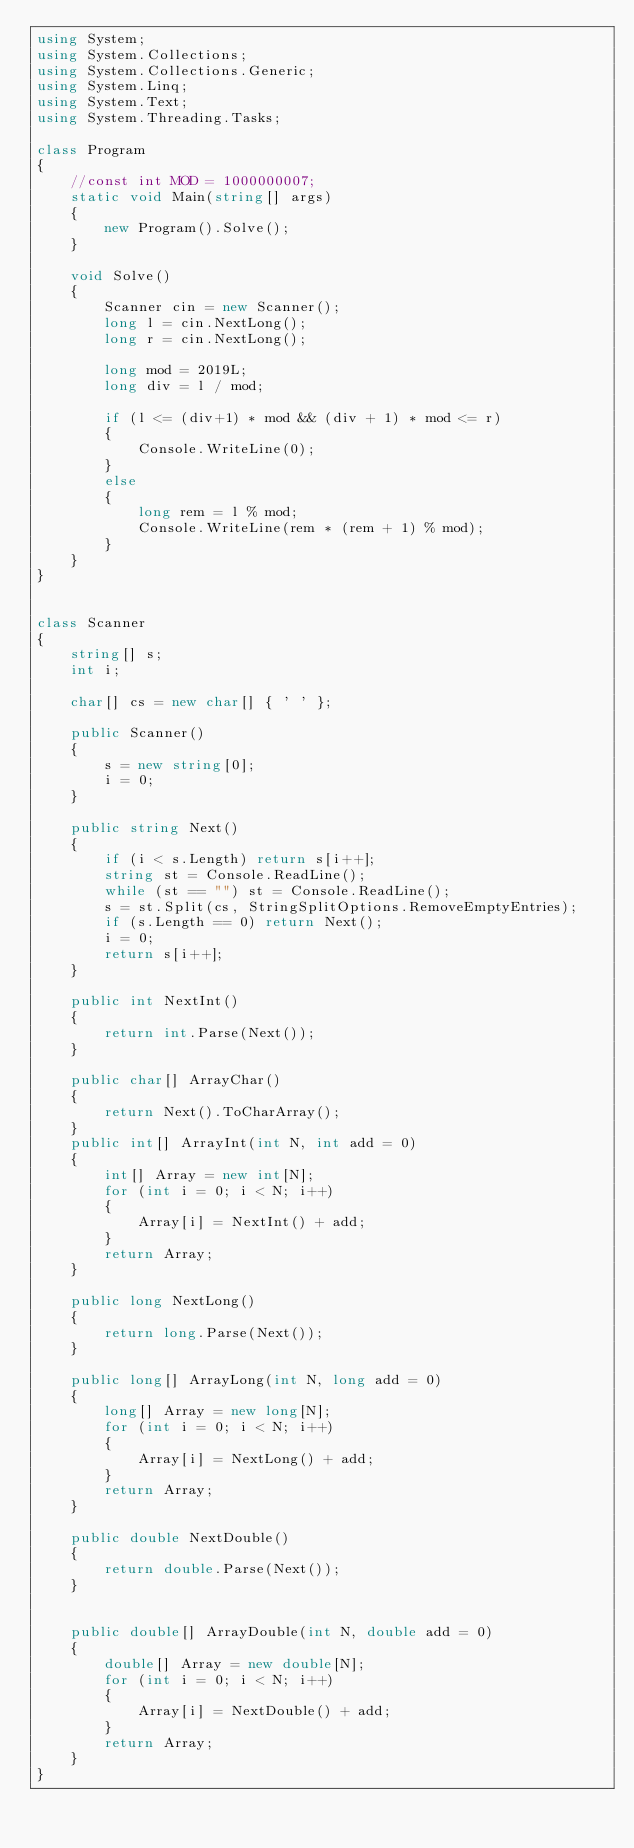<code> <loc_0><loc_0><loc_500><loc_500><_C#_>using System;
using System.Collections;
using System.Collections.Generic;
using System.Linq;
using System.Text;
using System.Threading.Tasks;

class Program
{
    //const int MOD = 1000000007;
    static void Main(string[] args)
    {
        new Program().Solve();
    }

    void Solve()
    {
        Scanner cin = new Scanner();
        long l = cin.NextLong();
        long r = cin.NextLong();

        long mod = 2019L;
        long div = l / mod;
        
        if (l <= (div+1) * mod && (div + 1) * mod <= r)
        {
            Console.WriteLine(0);
        }
        else
        {
            long rem = l % mod;
            Console.WriteLine(rem * (rem + 1) % mod);
        }
    }
}


class Scanner
{
    string[] s;
    int i;

    char[] cs = new char[] { ' ' };

    public Scanner()
    {
        s = new string[0];
        i = 0;
    }

    public string Next()
    {
        if (i < s.Length) return s[i++];
        string st = Console.ReadLine();
        while (st == "") st = Console.ReadLine();
        s = st.Split(cs, StringSplitOptions.RemoveEmptyEntries);
        if (s.Length == 0) return Next();
        i = 0;
        return s[i++];
    }

    public int NextInt()
    {
        return int.Parse(Next());
    }

    public char[] ArrayChar()
    {
        return Next().ToCharArray();
    }
    public int[] ArrayInt(int N, int add = 0)
    {
        int[] Array = new int[N];
        for (int i = 0; i < N; i++)
        {
            Array[i] = NextInt() + add;
        }
        return Array;
    }

    public long NextLong()
    {
        return long.Parse(Next());
    }

    public long[] ArrayLong(int N, long add = 0)
    {
        long[] Array = new long[N];
        for (int i = 0; i < N; i++)
        {
            Array[i] = NextLong() + add;
        }
        return Array;
    }

    public double NextDouble()
    {
        return double.Parse(Next());
    }


    public double[] ArrayDouble(int N, double add = 0)
    {
        double[] Array = new double[N];
        for (int i = 0; i < N; i++)
        {
            Array[i] = NextDouble() + add;
        }
        return Array;
    }
}
</code> 